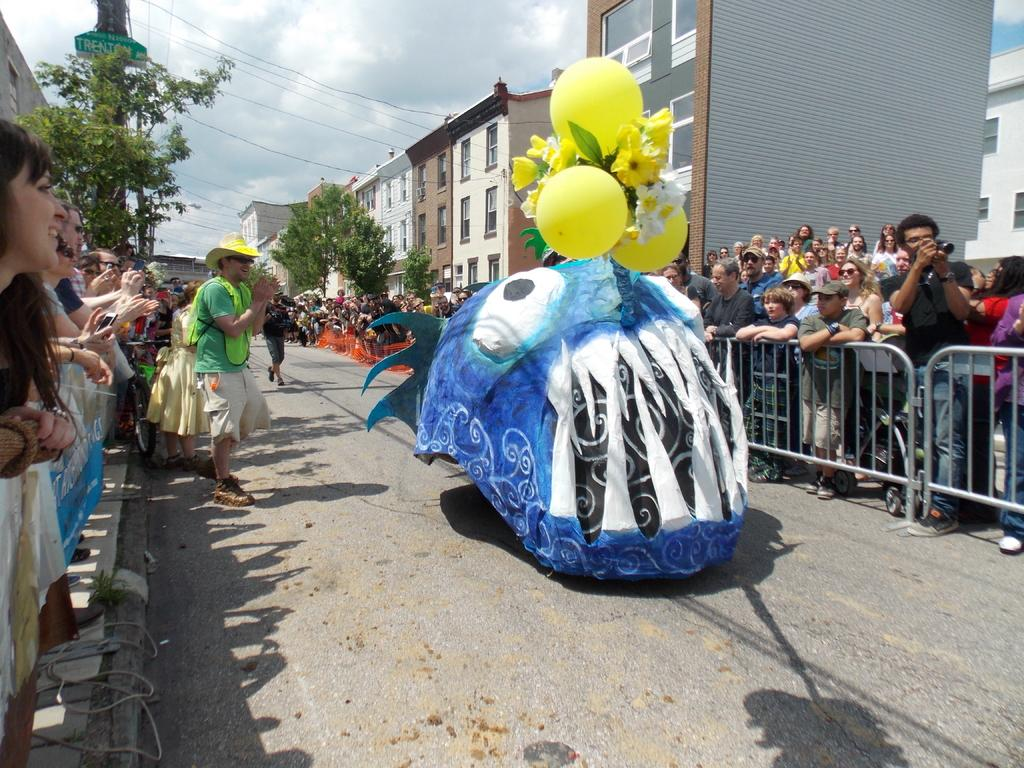What objects are present in the image that are typically used for celebrations or events? There are balloons in the image, which are often used for celebrations or events. Can you describe the people in the image? There are people in the image, but their specific actions or appearances are not mentioned in the facts. What type of structure can be seen in the image? There is a fence in the image, which is a type of structure. What else can be seen in the background of the image? There are buildings and trees in the image, as well as windows. How would you describe the weather based on the image? The sky is cloudy in the image, which suggests a potentially overcast or cloudy day. Who might be responsible for capturing the image? There is a person holding a camera in the image, so they might be responsible for capturing the image. Can you tell me how many ducks are visible in the image? There are no ducks present in the image. What type of railway is visible in the image? There is no railway present in the image. 